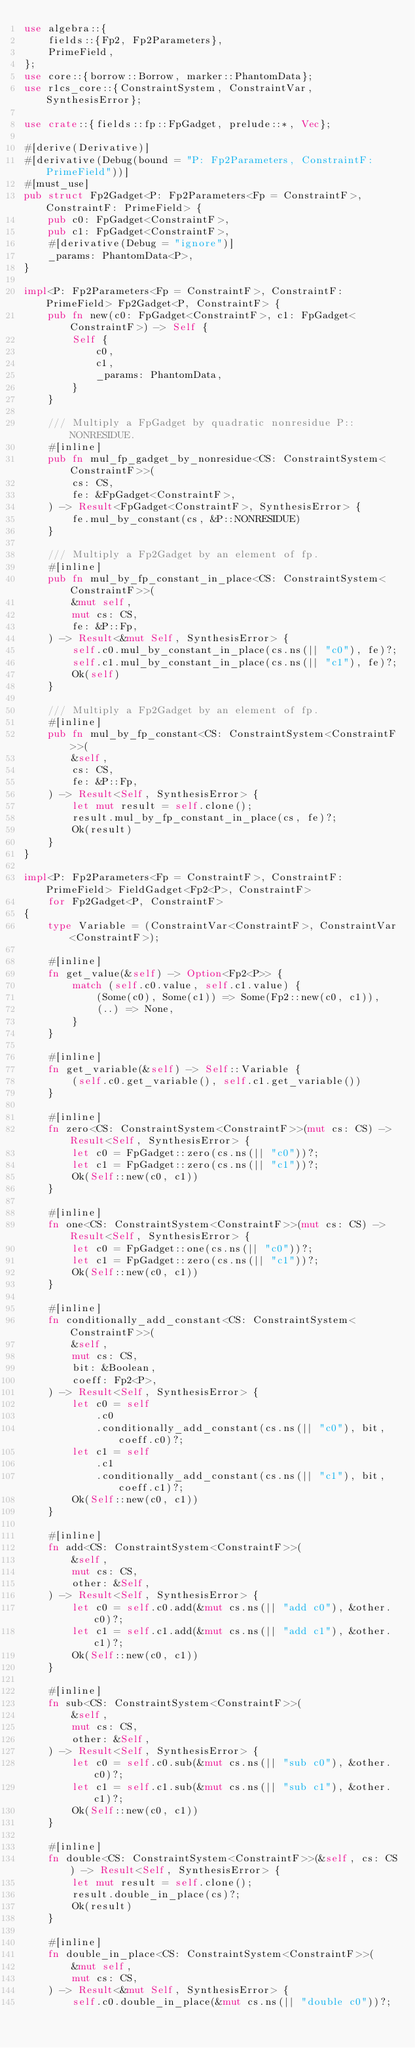<code> <loc_0><loc_0><loc_500><loc_500><_Rust_>use algebra::{
    fields::{Fp2, Fp2Parameters},
    PrimeField,
};
use core::{borrow::Borrow, marker::PhantomData};
use r1cs_core::{ConstraintSystem, ConstraintVar, SynthesisError};

use crate::{fields::fp::FpGadget, prelude::*, Vec};

#[derive(Derivative)]
#[derivative(Debug(bound = "P: Fp2Parameters, ConstraintF: PrimeField"))]
#[must_use]
pub struct Fp2Gadget<P: Fp2Parameters<Fp = ConstraintF>, ConstraintF: PrimeField> {
    pub c0: FpGadget<ConstraintF>,
    pub c1: FpGadget<ConstraintF>,
    #[derivative(Debug = "ignore")]
    _params: PhantomData<P>,
}

impl<P: Fp2Parameters<Fp = ConstraintF>, ConstraintF: PrimeField> Fp2Gadget<P, ConstraintF> {
    pub fn new(c0: FpGadget<ConstraintF>, c1: FpGadget<ConstraintF>) -> Self {
        Self {
            c0,
            c1,
            _params: PhantomData,
        }
    }

    /// Multiply a FpGadget by quadratic nonresidue P::NONRESIDUE.
    #[inline]
    pub fn mul_fp_gadget_by_nonresidue<CS: ConstraintSystem<ConstraintF>>(
        cs: CS,
        fe: &FpGadget<ConstraintF>,
    ) -> Result<FpGadget<ConstraintF>, SynthesisError> {
        fe.mul_by_constant(cs, &P::NONRESIDUE)
    }

    /// Multiply a Fp2Gadget by an element of fp.
    #[inline]
    pub fn mul_by_fp_constant_in_place<CS: ConstraintSystem<ConstraintF>>(
        &mut self,
        mut cs: CS,
        fe: &P::Fp,
    ) -> Result<&mut Self, SynthesisError> {
        self.c0.mul_by_constant_in_place(cs.ns(|| "c0"), fe)?;
        self.c1.mul_by_constant_in_place(cs.ns(|| "c1"), fe)?;
        Ok(self)
    }

    /// Multiply a Fp2Gadget by an element of fp.
    #[inline]
    pub fn mul_by_fp_constant<CS: ConstraintSystem<ConstraintF>>(
        &self,
        cs: CS,
        fe: &P::Fp,
    ) -> Result<Self, SynthesisError> {
        let mut result = self.clone();
        result.mul_by_fp_constant_in_place(cs, fe)?;
        Ok(result)
    }
}

impl<P: Fp2Parameters<Fp = ConstraintF>, ConstraintF: PrimeField> FieldGadget<Fp2<P>, ConstraintF>
    for Fp2Gadget<P, ConstraintF>
{
    type Variable = (ConstraintVar<ConstraintF>, ConstraintVar<ConstraintF>);

    #[inline]
    fn get_value(&self) -> Option<Fp2<P>> {
        match (self.c0.value, self.c1.value) {
            (Some(c0), Some(c1)) => Some(Fp2::new(c0, c1)),
            (..) => None,
        }
    }

    #[inline]
    fn get_variable(&self) -> Self::Variable {
        (self.c0.get_variable(), self.c1.get_variable())
    }

    #[inline]
    fn zero<CS: ConstraintSystem<ConstraintF>>(mut cs: CS) -> Result<Self, SynthesisError> {
        let c0 = FpGadget::zero(cs.ns(|| "c0"))?;
        let c1 = FpGadget::zero(cs.ns(|| "c1"))?;
        Ok(Self::new(c0, c1))
    }

    #[inline]
    fn one<CS: ConstraintSystem<ConstraintF>>(mut cs: CS) -> Result<Self, SynthesisError> {
        let c0 = FpGadget::one(cs.ns(|| "c0"))?;
        let c1 = FpGadget::zero(cs.ns(|| "c1"))?;
        Ok(Self::new(c0, c1))
    }

    #[inline]
    fn conditionally_add_constant<CS: ConstraintSystem<ConstraintF>>(
        &self,
        mut cs: CS,
        bit: &Boolean,
        coeff: Fp2<P>,
    ) -> Result<Self, SynthesisError> {
        let c0 = self
            .c0
            .conditionally_add_constant(cs.ns(|| "c0"), bit, coeff.c0)?;
        let c1 = self
            .c1
            .conditionally_add_constant(cs.ns(|| "c1"), bit, coeff.c1)?;
        Ok(Self::new(c0, c1))
    }

    #[inline]
    fn add<CS: ConstraintSystem<ConstraintF>>(
        &self,
        mut cs: CS,
        other: &Self,
    ) -> Result<Self, SynthesisError> {
        let c0 = self.c0.add(&mut cs.ns(|| "add c0"), &other.c0)?;
        let c1 = self.c1.add(&mut cs.ns(|| "add c1"), &other.c1)?;
        Ok(Self::new(c0, c1))
    }

    #[inline]
    fn sub<CS: ConstraintSystem<ConstraintF>>(
        &self,
        mut cs: CS,
        other: &Self,
    ) -> Result<Self, SynthesisError> {
        let c0 = self.c0.sub(&mut cs.ns(|| "sub c0"), &other.c0)?;
        let c1 = self.c1.sub(&mut cs.ns(|| "sub c1"), &other.c1)?;
        Ok(Self::new(c0, c1))
    }

    #[inline]
    fn double<CS: ConstraintSystem<ConstraintF>>(&self, cs: CS) -> Result<Self, SynthesisError> {
        let mut result = self.clone();
        result.double_in_place(cs)?;
        Ok(result)
    }

    #[inline]
    fn double_in_place<CS: ConstraintSystem<ConstraintF>>(
        &mut self,
        mut cs: CS,
    ) -> Result<&mut Self, SynthesisError> {
        self.c0.double_in_place(&mut cs.ns(|| "double c0"))?;</code> 